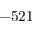<formula> <loc_0><loc_0><loc_500><loc_500>- 5 2 1</formula> 